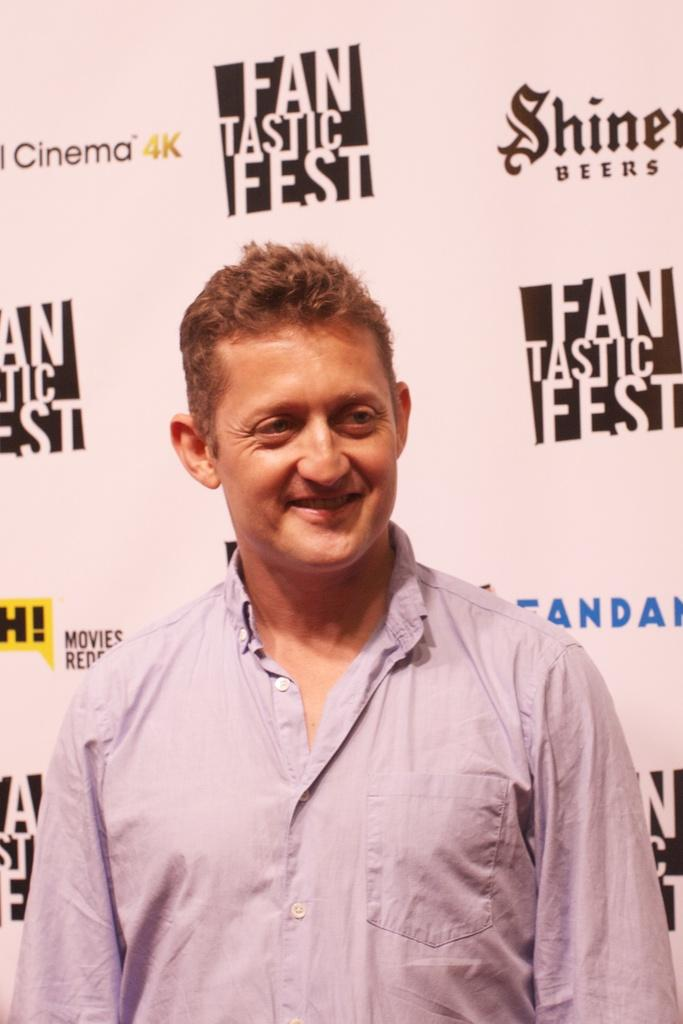<image>
Write a terse but informative summary of the picture. Man standing in front of a fantastic fest wallpaper 